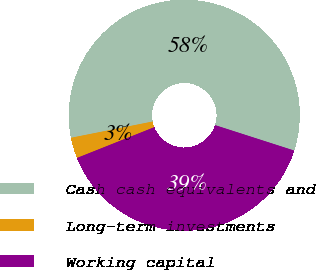<chart> <loc_0><loc_0><loc_500><loc_500><pie_chart><fcel>Cash cash equivalents and<fcel>Long-term investments<fcel>Working capital<nl><fcel>58.08%<fcel>2.9%<fcel>39.02%<nl></chart> 